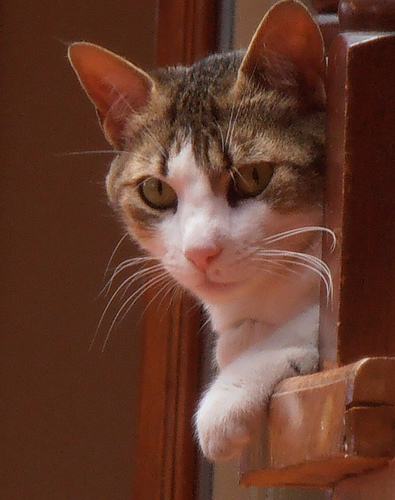<image>
Can you confirm if the whiskers is on the cat? Yes. Looking at the image, I can see the whiskers is positioned on top of the cat, with the cat providing support. Where is the wall in relation to the cat? Is it to the right of the cat? Yes. From this viewpoint, the wall is positioned to the right side relative to the cat. 